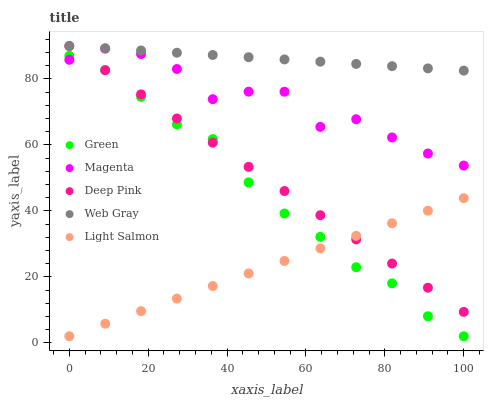Does Light Salmon have the minimum area under the curve?
Answer yes or no. Yes. Does Web Gray have the maximum area under the curve?
Answer yes or no. Yes. Does Magenta have the minimum area under the curve?
Answer yes or no. No. Does Magenta have the maximum area under the curve?
Answer yes or no. No. Is Light Salmon the smoothest?
Answer yes or no. Yes. Is Magenta the roughest?
Answer yes or no. Yes. Is Deep Pink the smoothest?
Answer yes or no. No. Is Deep Pink the roughest?
Answer yes or no. No. Does Green have the lowest value?
Answer yes or no. Yes. Does Magenta have the lowest value?
Answer yes or no. No. Does Deep Pink have the highest value?
Answer yes or no. Yes. Does Magenta have the highest value?
Answer yes or no. No. Is Magenta less than Web Gray?
Answer yes or no. Yes. Is Web Gray greater than Magenta?
Answer yes or no. Yes. Does Deep Pink intersect Green?
Answer yes or no. Yes. Is Deep Pink less than Green?
Answer yes or no. No. Is Deep Pink greater than Green?
Answer yes or no. No. Does Magenta intersect Web Gray?
Answer yes or no. No. 